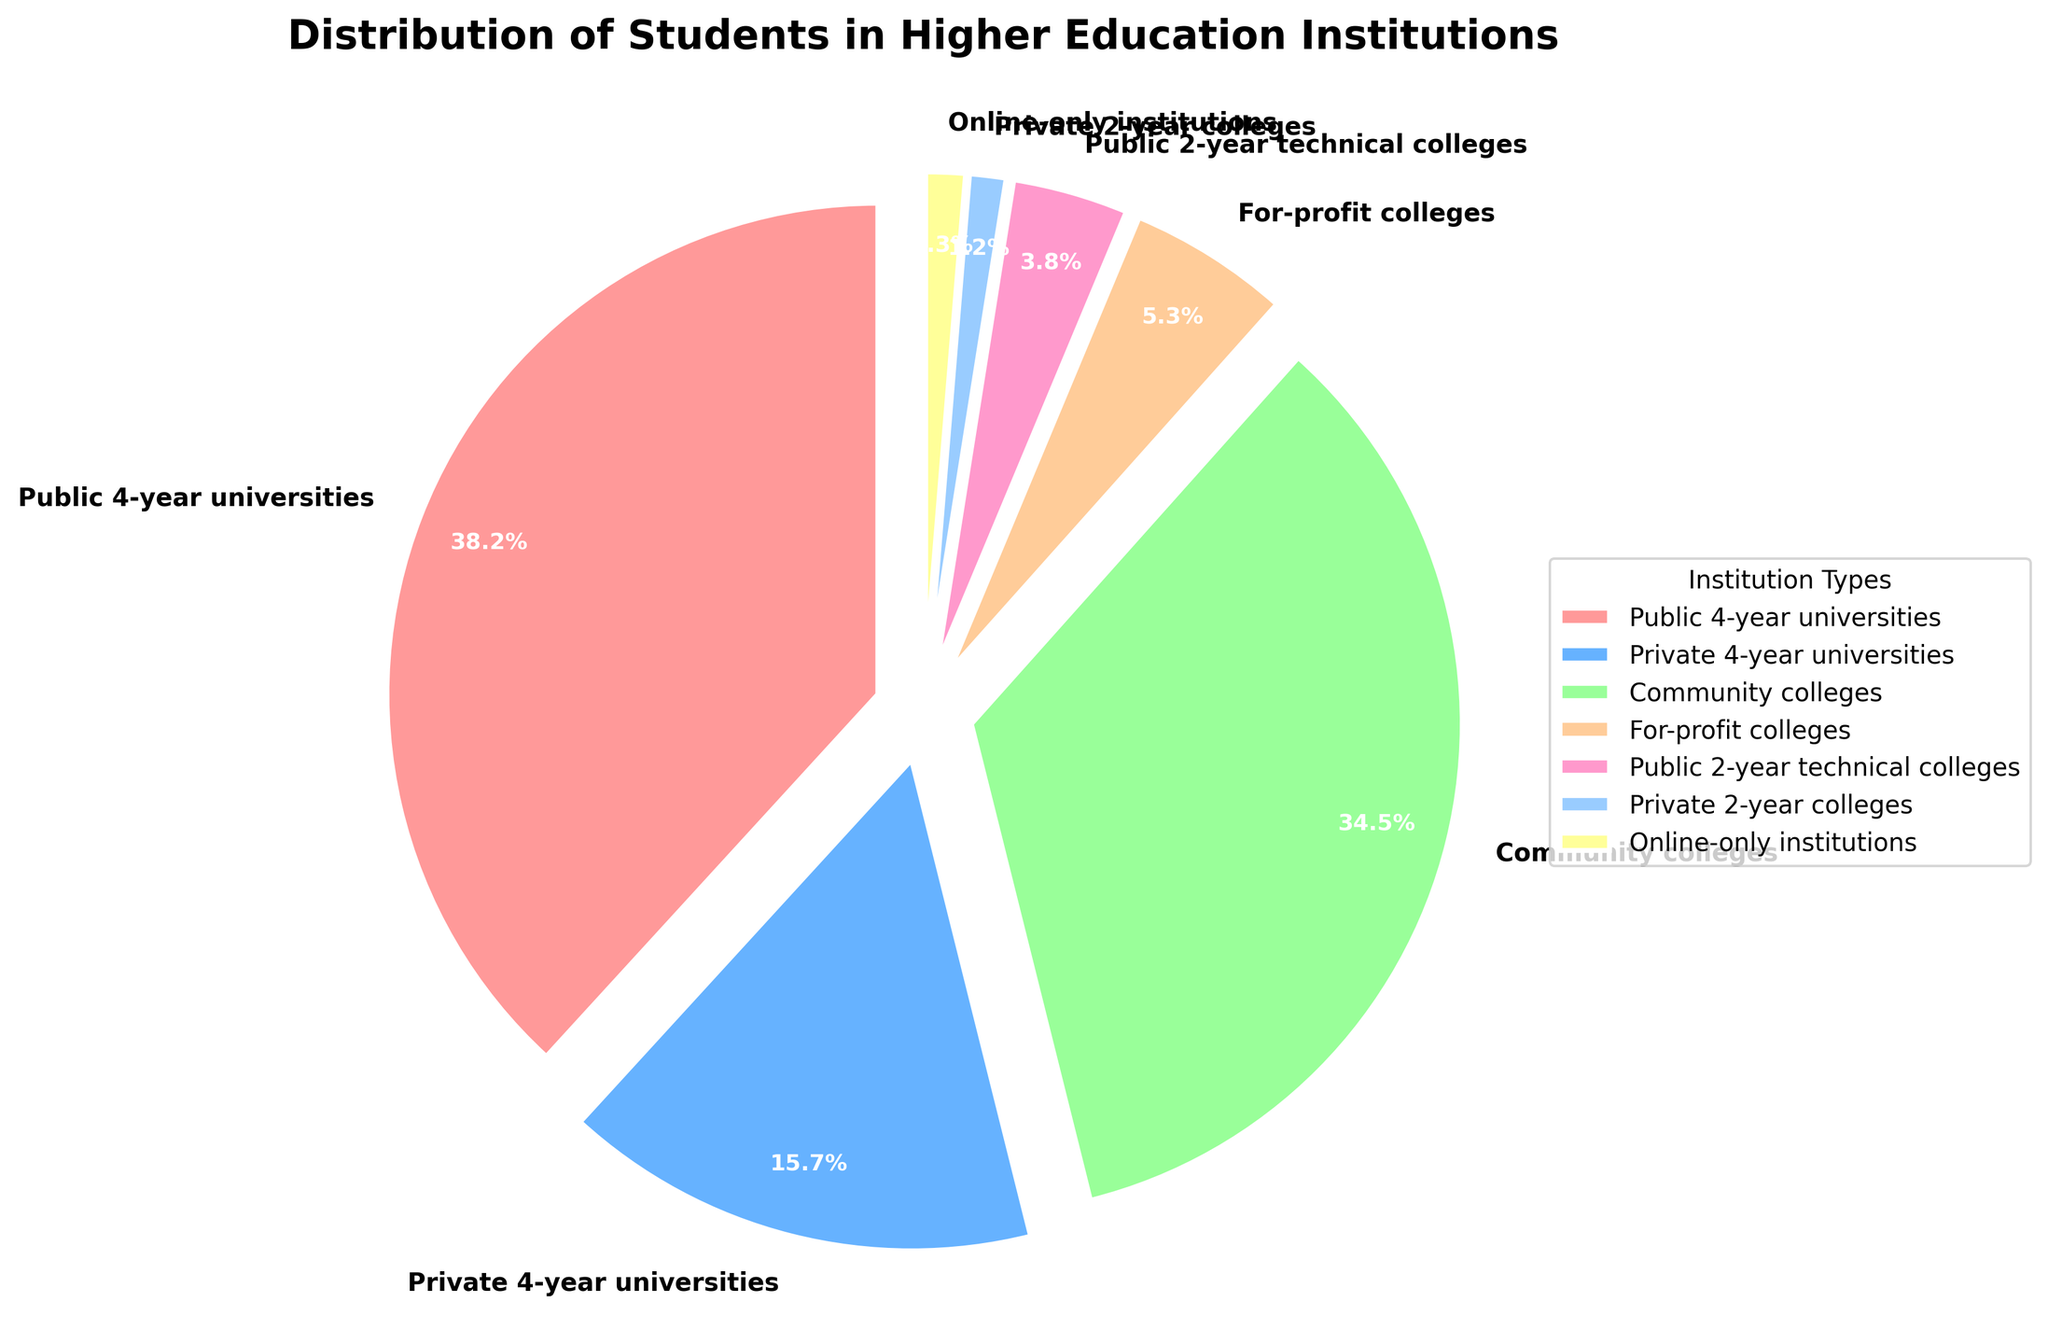What percentage of students attend public 4-year universities? The slice labeled "Public 4-year universities" shows the percentage directly.
Answer: 38.2% What is the combined percentage of students attending community colleges and public 2-year technical colleges? Add the percentages for "Community colleges" and "Public 2-year technical colleges." 34.5 + 3.8 = 38.3%
Answer: 38.3% Which institution type has the smallest percentage of students and what is that percentage? Identify the smallest slice from the figure. It's labeled "Private 2-year colleges" with 1.2%.
Answer: Private 2-year colleges, 1.2% How much larger is the percentage of students attending public 4-year universities compared to private 4-year universities? Subtract the percentage of "Private 4-year universities" from "Public 4-year universities." 38.2 - 15.7 = 22.5%
Answer: 22.5% Which two types of institutions have similar percentages of students attending, and what are those percentages? Look at slices with close percentages. "Online-only institutions" (1.3%) and "Private 2-year colleges" (1.2%) are closest.
Answer: Online-only institutions (1.3%) and Private 2-year colleges (1.2%) What is the total percentage of students attending non-4-year institutions (community colleges, public 2-year technical colleges, private 2-year colleges, and online-only institutions)? Add the percentages for these institution types. 34.5 + 3.8 + 1.2 + 1.3 = 40.8%
Answer: 40.8% Which institution type occupies a blue slice in the pie chart? Identify the color assigned to each slice. The blue slice is labeled "Private 4-year universities."
Answer: Private 4-year universities What percentage of students attend institutions that are either for-profit or online-only? Add the percentages for "For-profit colleges" and "Online-only institutions." 5.3 + 1.3 = 6.6%
Answer: 6.6% Is the percentage of students attending public 4-year universities more than double of those attending private 4-year universities? Compare if 38.2% is more than double of 15.7%. Double of 15.7 is 31.4, and 38.2 is larger.
Answer: Yes How much more popular are community colleges compared to for-profit colleges in terms of student attendance percentage? Subtract the percentage of "For-profit colleges" from "Community colleges." 34.5 - 5.3 = 29.2%
Answer: 29.2% 